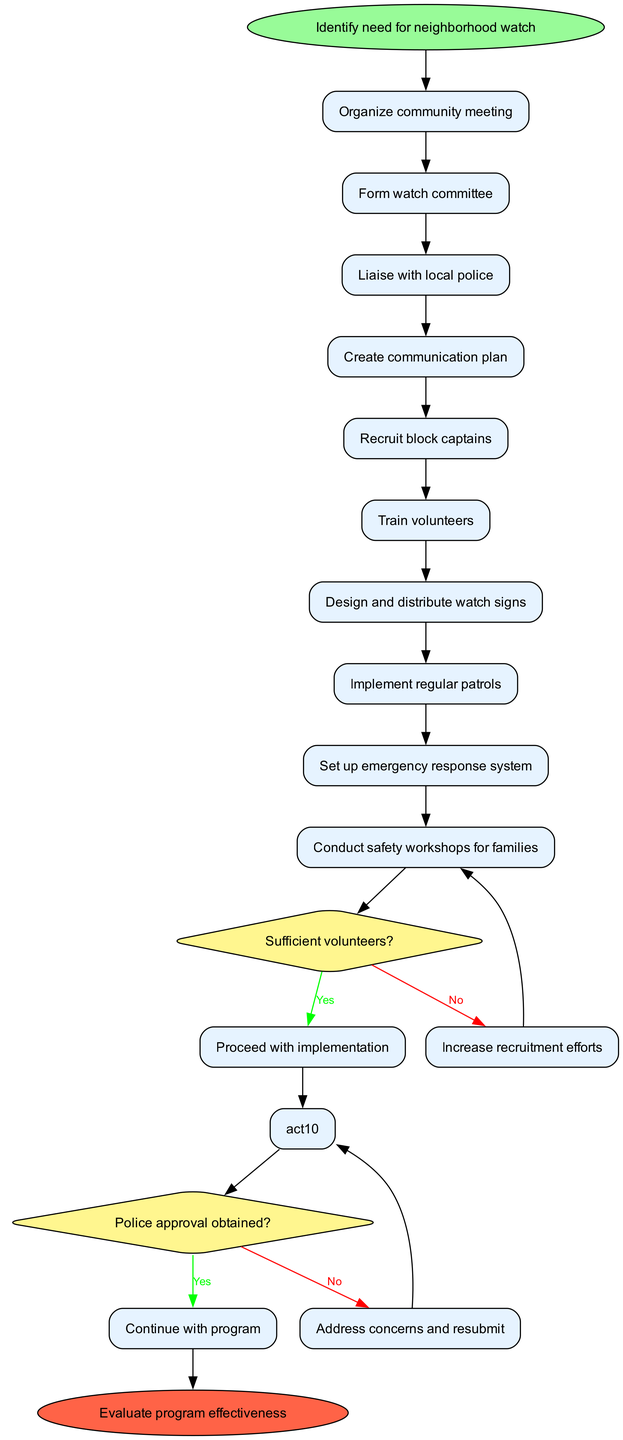What is the first step in the neighborhood watch program? The diagram begins with the node labeled "Identify need for neighborhood watch," indicating this is the first step in the process.
Answer: Identify need for neighborhood watch How many activities are listed in the diagram? There are ten activities outlined in the diagram, as counted individually from the activities section.
Answer: 10 What are the two decision points in the diagram? The decision nodes ask, "Sufficient volunteers?" and "Police approval obtained?" These are the two key decision points before proceeding in the diagram.
Answer: Sufficient volunteers? and Police approval obtained? What happens if there are not sufficient volunteers? The diagram shows that if the answer to "Sufficient volunteers?" is No, then the process leads to "Increase recruitment efforts," indicating the next action to take.
Answer: Increase recruitment efforts If police approval is obtained, what is the next node? According to the flow, if "Police approval obtained?" is Yes, it leads to the next steps, ultimately continuing with the program towards implementation.
Answer: Continue with program What is the last step in the neighborhood watch program? The final step in the diagram is represented by the node labeled "Evaluate program effectiveness," showing that assessment occurs after implementation.
Answer: Evaluate program effectiveness How many activities follow the decision point of sufficient volunteers? After the decision node for sufficient volunteers, there are four distinct activities that follow, specifically from "Design and distribute watch signs" onwards.
Answer: 4 Which activity is directly before the decision point about police approval? The activity "Train volunteers" is the last activity before the decision point regarding police approval in the flow of the diagram.
Answer: Train volunteers What will be the outcome if there is no police approval? If the answer to the police approval question is No, the process directs to "Address concerns and resubmit," indicating a need to resolve issues before proceeding.
Answer: Address concerns and resubmit 